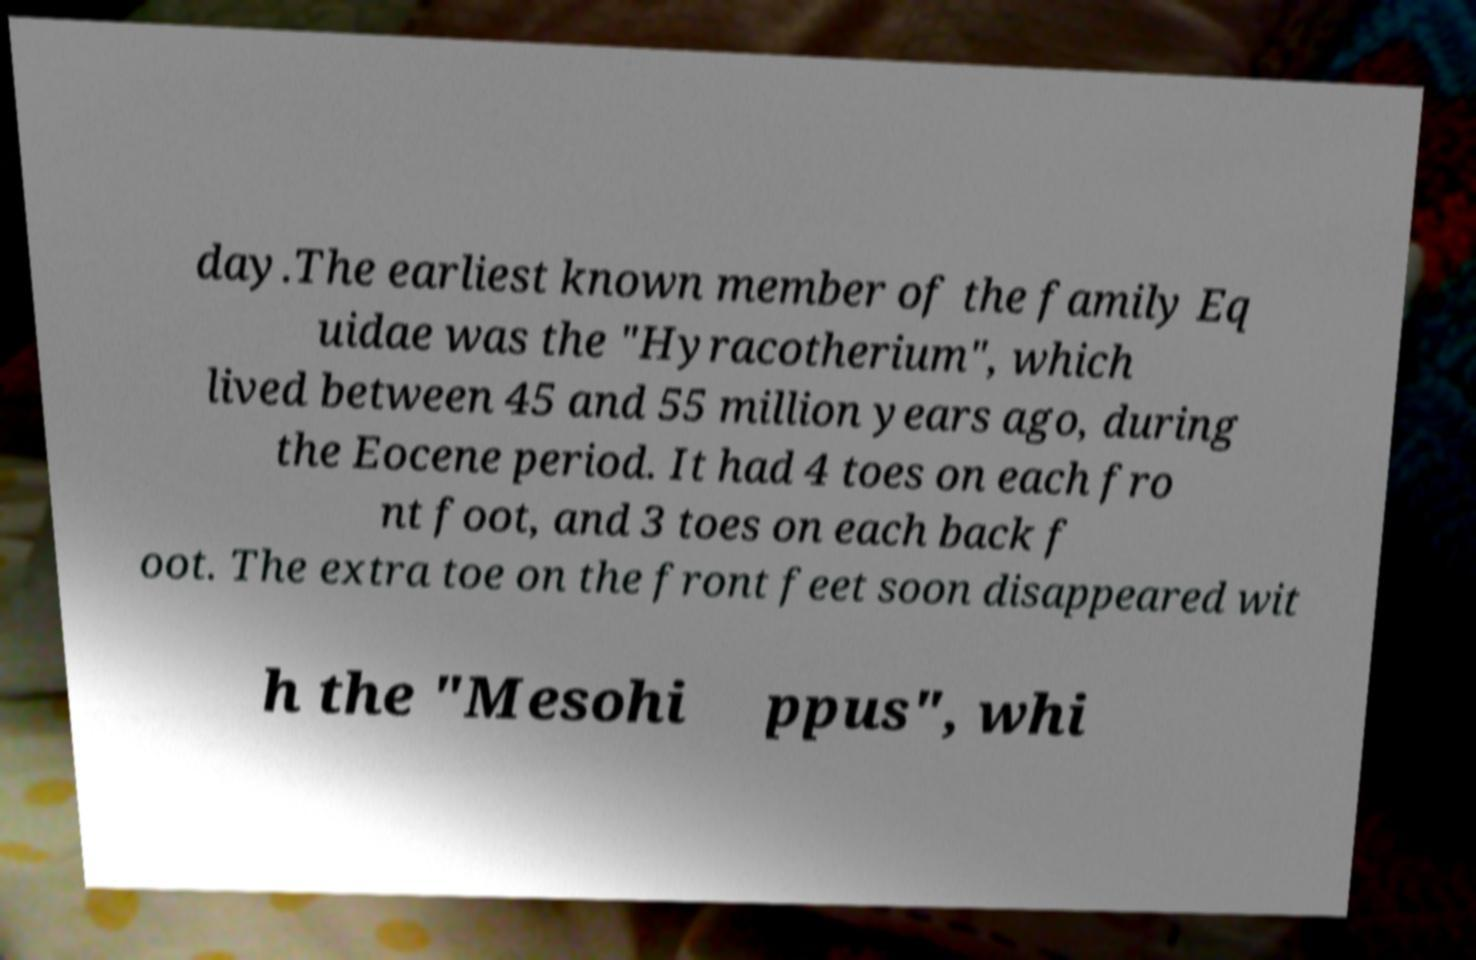Could you extract and type out the text from this image? day.The earliest known member of the family Eq uidae was the "Hyracotherium", which lived between 45 and 55 million years ago, during the Eocene period. It had 4 toes on each fro nt foot, and 3 toes on each back f oot. The extra toe on the front feet soon disappeared wit h the "Mesohi ppus", whi 